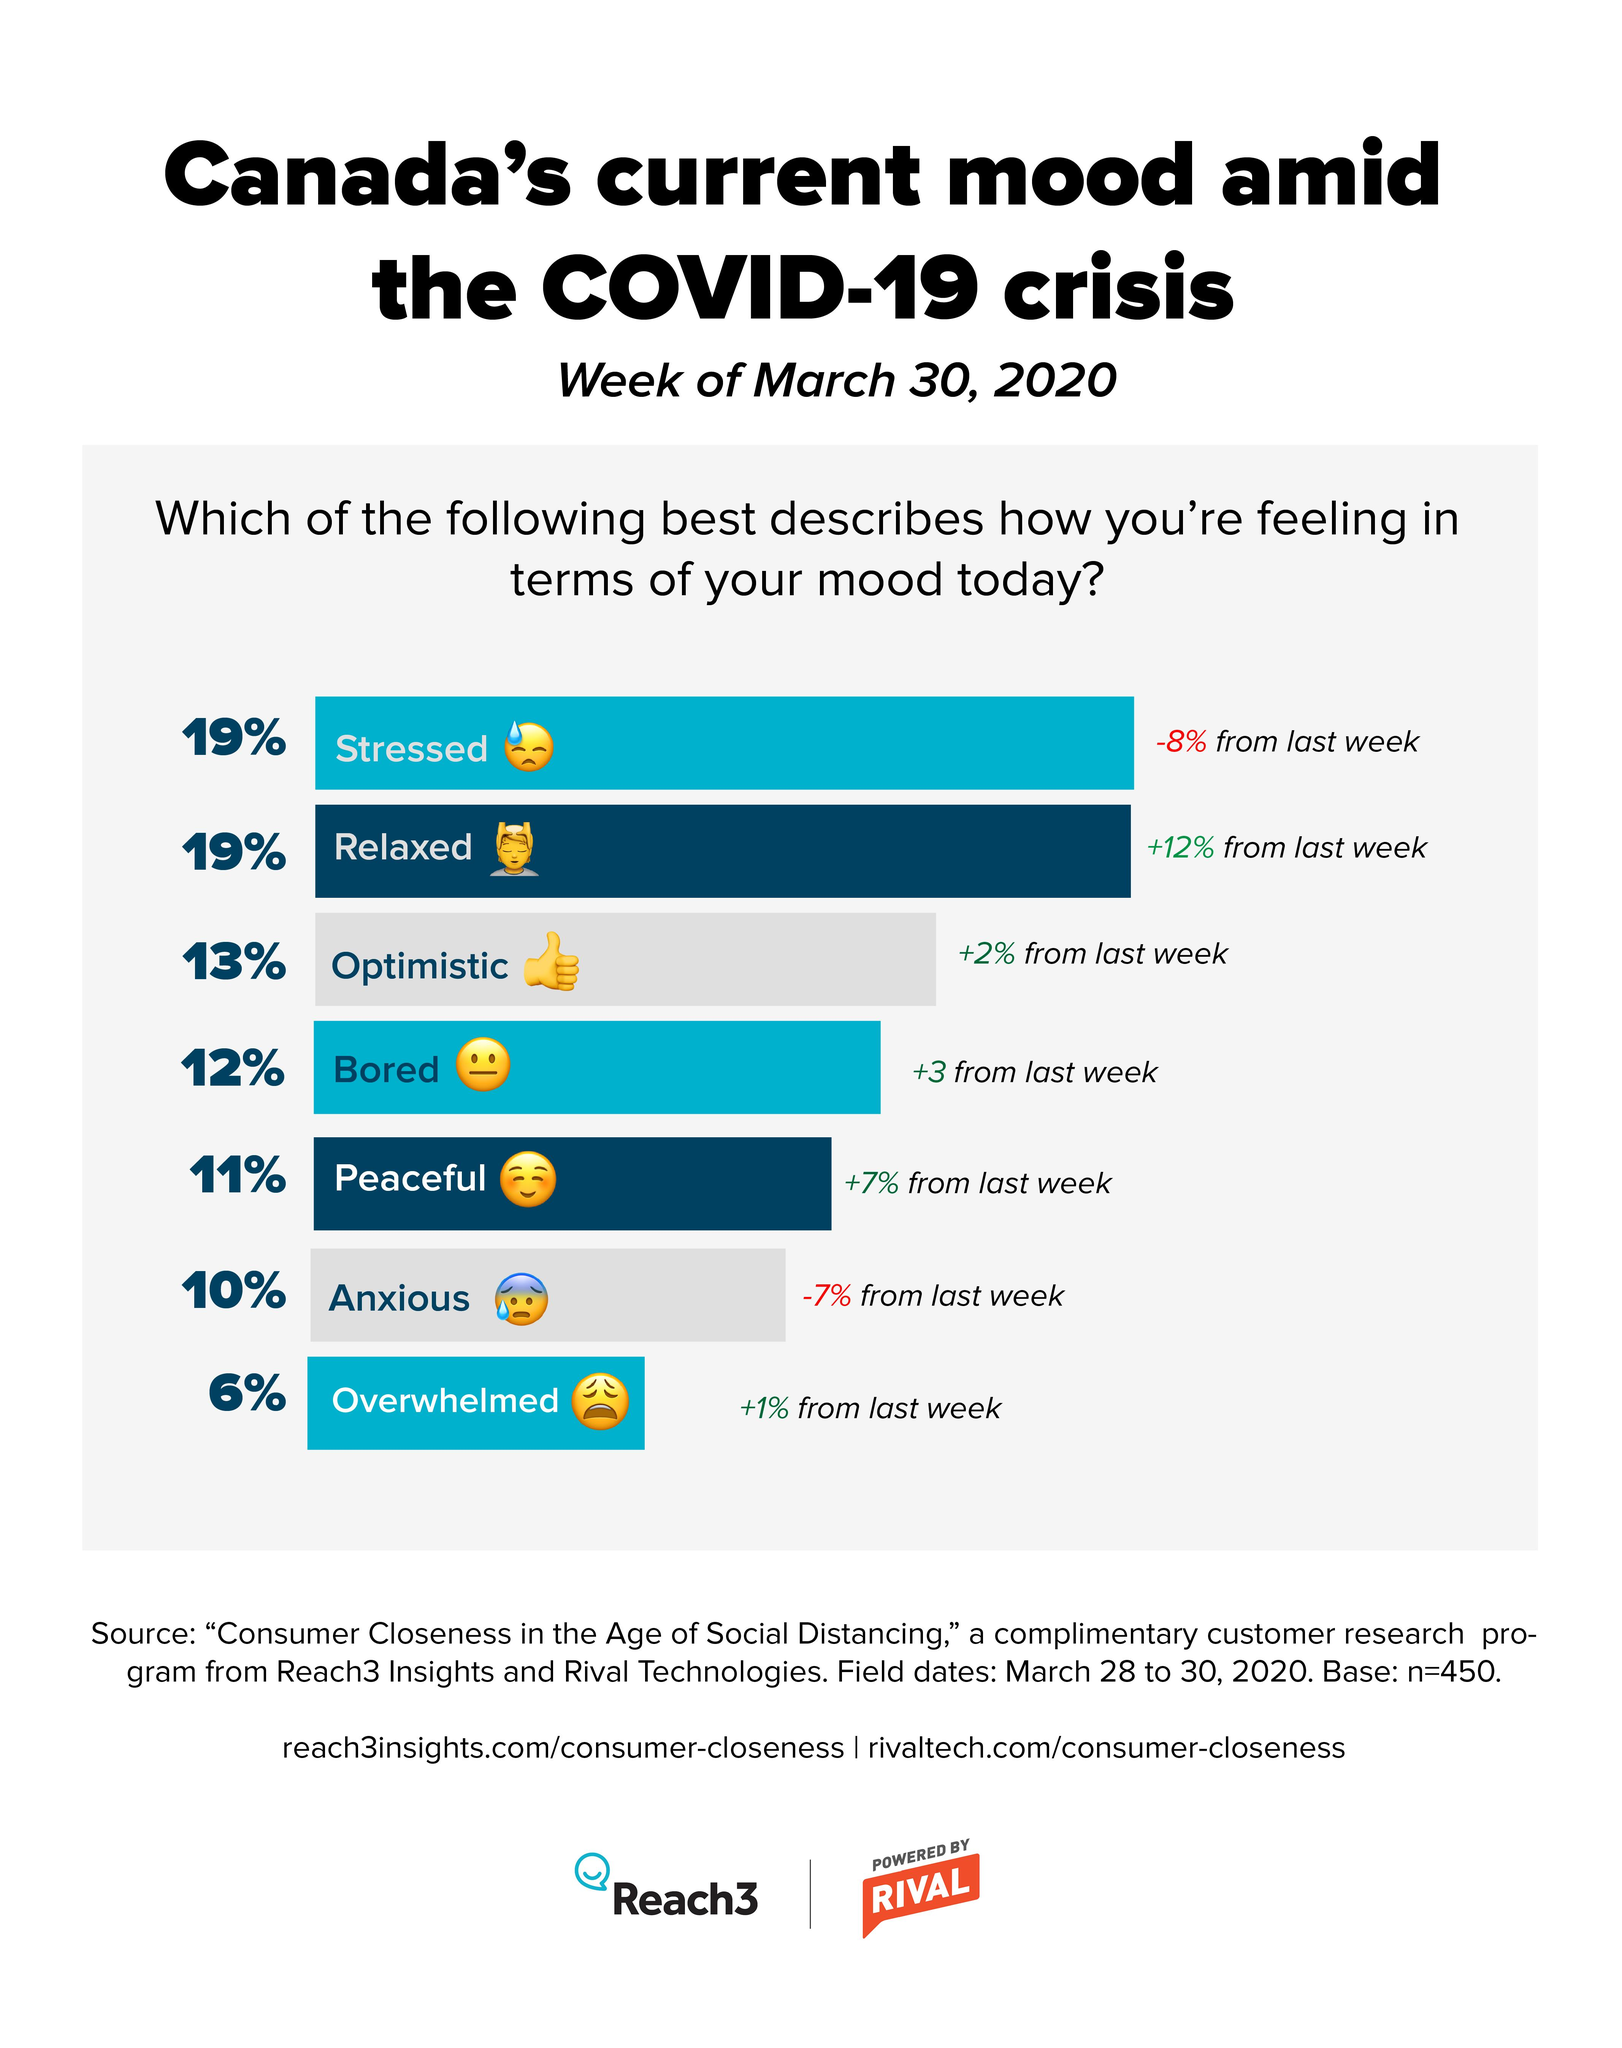Mention a couple of crucial points in this snapshot. According to a survey conducted in the week of March 30, 2020, approximately 6% of Canadians reported feeling overwhelmed amid the COVID-19 crisis. According to a survey conducted in the week of March 30, 2020, 11% of Canadians felt peaceful during the COVID-19 crisis. In a survey conducted in the week of March 30, 2020, 12% of Canadians reported feeling bored amid the COVID-19 crisis, indicating that a significant portion of the population was affected by the ongoing pandemic. A survey conducted in the week of March 30, 2020, found that 10% of Canadians felt anxious amid the COVID-19 crisis. A survey conducted in Canada during the week of March 30, 2020, revealed that 19% of the population reported feeling stressed during the COVID-19 crisis. 